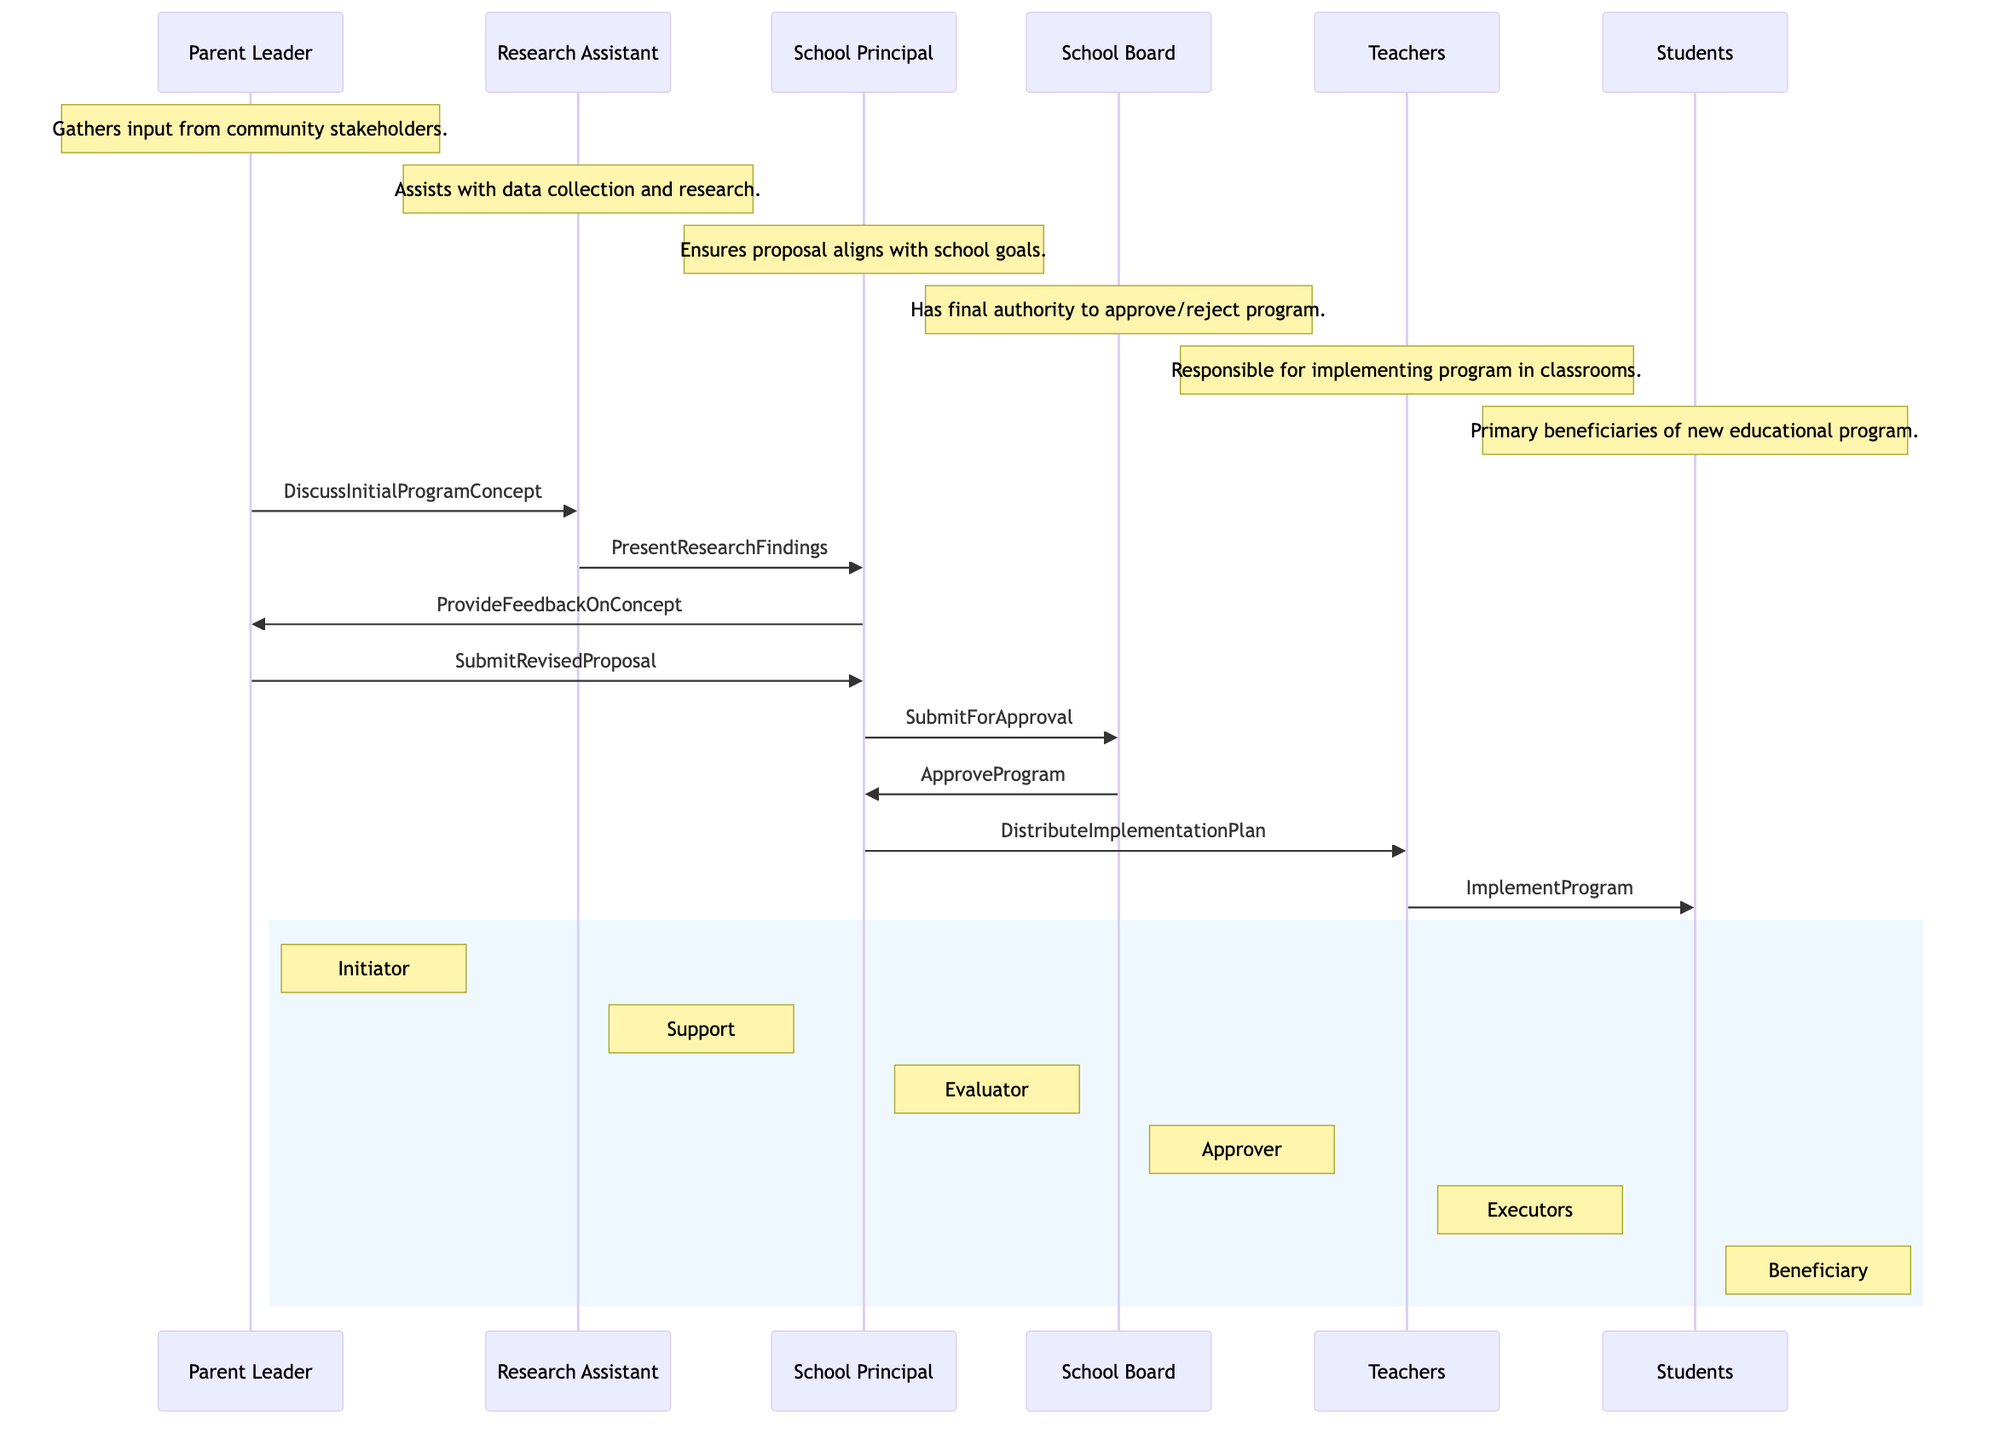What's the total number of actors in the diagram? The diagram lists six actors: Parent Leader, Research Assistant, School Principal, School Board, Teachers, and Students. Therefore, the total count is 6.
Answer: 6 Who initiates the proposal in the diagram? The diagram shows the Parent Leader as the one who initiates the proposal, as indicated by their role as Initiator.
Answer: Parent Leader Which actor evaluates the proposal? The role of Evaluator in the diagram is assigned to the School Principal, who assesses the proposal's validity before approval.
Answer: School Principal How many messages are exchanged before the School Board approves the program? Counting the messages exchanged prior to the School Board's approval, there are five messages listed, culminating with the School Board's decision.
Answer: 5 What is the last action taken by the School Principal? The final action indicated by the School Principal is to distribute the implementation plan to the Teachers, marking their last interaction in the sequence.
Answer: DistributeImplementationPlan What role does the Research Assistant play in this process? The Research Assistant's role in the process is to assist in research, which entails collecting and presenting findings to relevant stakeholders.
Answer: AssistInResearch What feedback does the School Principal provide to the Parent Leader? The School Principal offers feedback on the initial program concept to the Parent Leader, which is an essential step in refining the proposal.
Answer: ProvideFeedbackOnConcept Which actor implements the program? The responsible actor for implementing the program in classrooms are the Teachers, who execute the plan after receiving it.
Answer: Teachers Which actor is the primary beneficiary of the educational program? The primary beneficiaries of the new educational program, as indicated in the diagram, are the Students, who participate directly in the program activities.
Answer: Students 